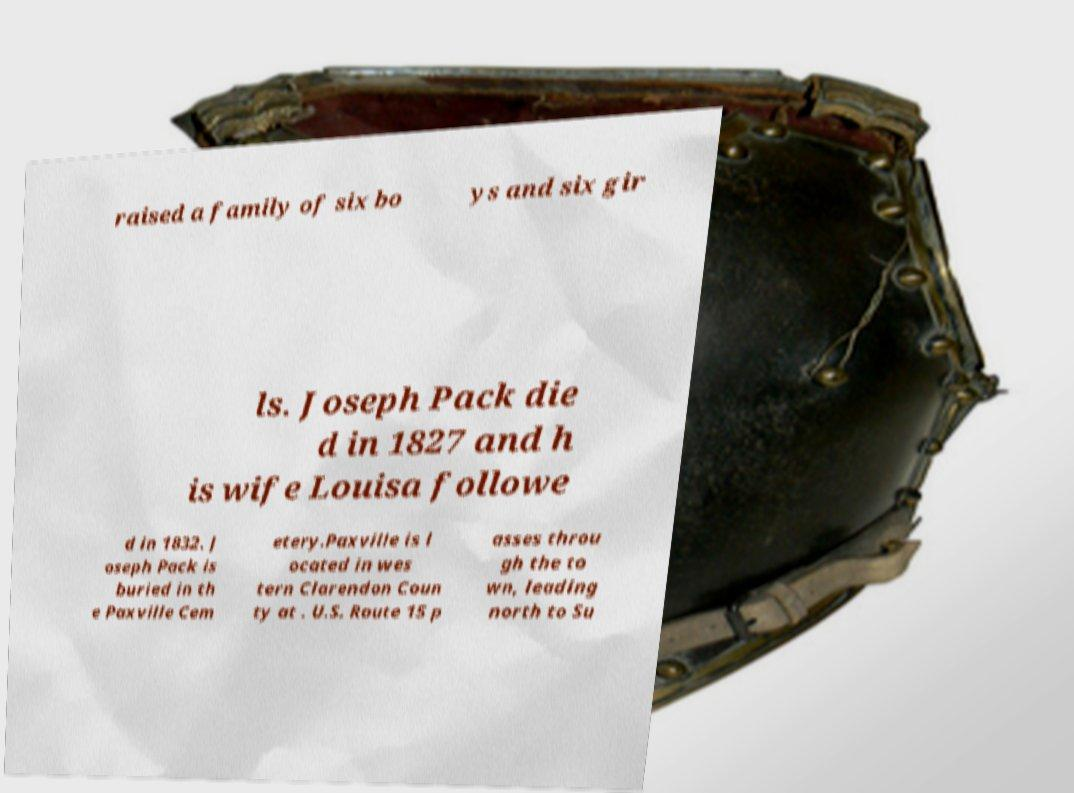Could you assist in decoding the text presented in this image and type it out clearly? raised a family of six bo ys and six gir ls. Joseph Pack die d in 1827 and h is wife Louisa followe d in 1832. J oseph Pack is buried in th e Paxville Cem etery.Paxville is l ocated in wes tern Clarendon Coun ty at . U.S. Route 15 p asses throu gh the to wn, leading north to Su 